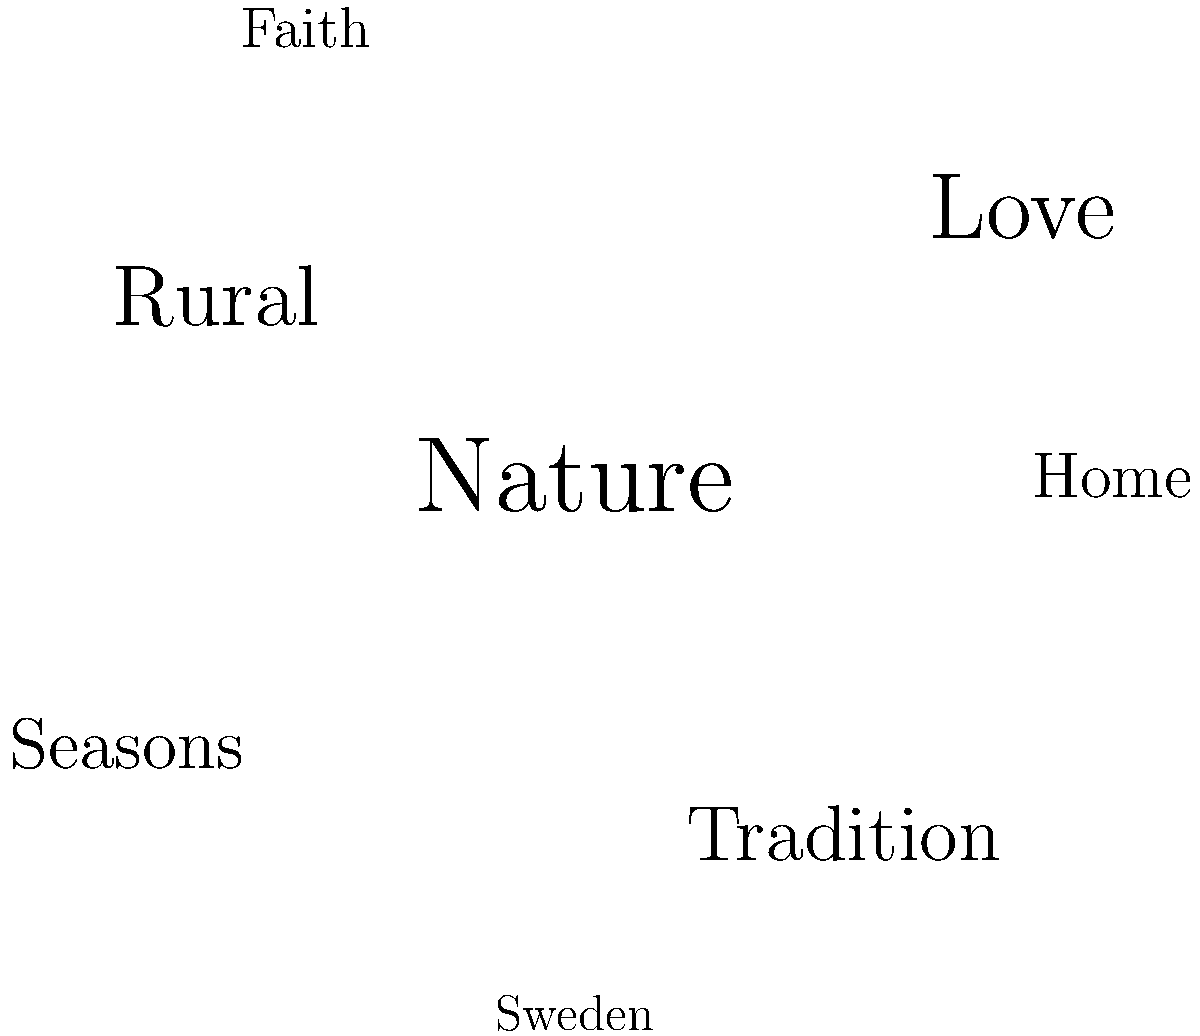Based on the word cloud representing themes in Erik Axel Karlfeldt's poetry, which two elements appear to be the most prominent, and how might these reflect his literary style and the Swedish cultural context of his time? To answer this question, we need to analyze the word cloud and consider Karlfeldt's literary context:

1. Observe the word cloud: The largest words are "Nature" and "Love", indicating they are the most prominent themes in Karlfeldt's poetry.

2. Consider Karlfeldt's style: As a Swedish poet active in the late 19th and early 20th centuries, Karlfeldt was known for his lyrical poetry that often celebrated rural life and nature.

3. Analyze "Nature" as a theme: 
   - Karlfeldt frequently used natural imagery in his poems.
   - This reflects the importance of nature in Swedish culture and the country's vast, diverse landscapes.

4. Examine "Love" as a theme:
   - Love is a universal poetic theme, but Karlfeldt often connected it to nature and rural life.
   - His love poetry often had a pastoral quality, linking romantic feelings to the natural world.

5. Connect to Swedish cultural context:
   - The prominence of "Nature" and "Love" reflects the Romantic and post-Romantic traditions in Swedish literature.
   - These themes also connect to the concept of "hembygd" (homeland), which was important in Swedish culture at the time.

6. Consider other words in the cloud:
   - "Rural," "Tradition," and "Home" support the emphasis on nature and Swedish cultural identity.
   - "Seasons" connects to the cyclical nature of rural life and the strong presence of seasonal changes in Sweden.

7. Conclusion: The prominence of "Nature" and "Love" in Karlfeldt's poetry reflects his focus on the Swedish landscape, rural traditions, and the connection between human emotions and the natural world, all of which were significant in the Swedish cultural context of his time.
Answer: Nature and Love; they reflect Karlfeldt's focus on rural Swedish life and the connection between human emotions and the natural world. 